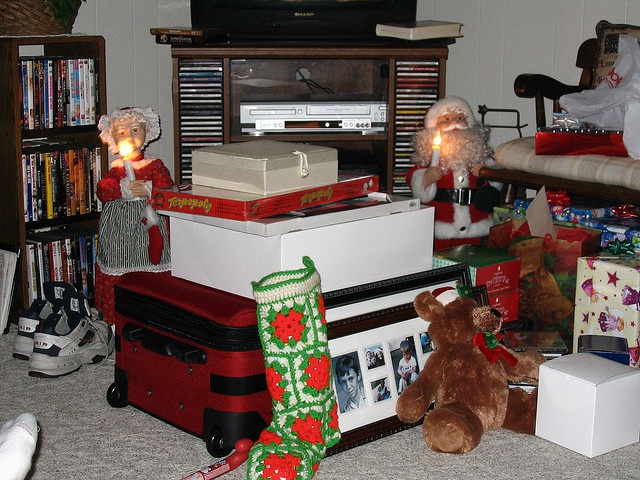Describe the objects in this image and their specific colors. I can see suitcase in black, maroon, and gray tones, chair in black, gray, and maroon tones, teddy bear in black, maroon, gray, and brown tones, book in black, gray, maroon, and darkgray tones, and people in black, maroon, gray, and darkgray tones in this image. 